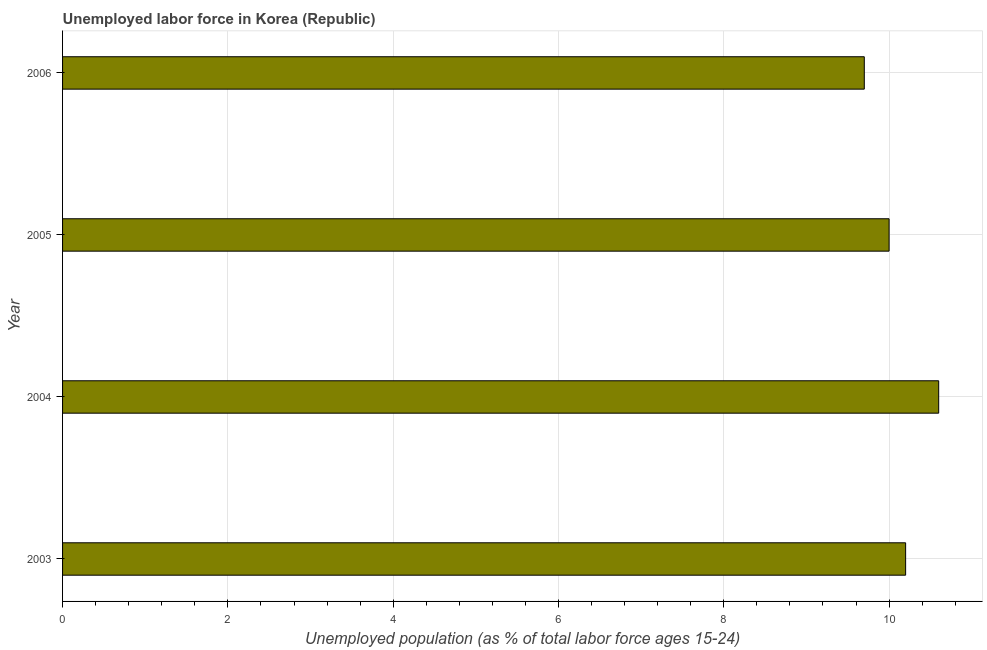Does the graph contain any zero values?
Offer a terse response. No. What is the title of the graph?
Provide a short and direct response. Unemployed labor force in Korea (Republic). What is the label or title of the X-axis?
Make the answer very short. Unemployed population (as % of total labor force ages 15-24). What is the label or title of the Y-axis?
Offer a terse response. Year. Across all years, what is the maximum total unemployed youth population?
Keep it short and to the point. 10.6. Across all years, what is the minimum total unemployed youth population?
Offer a terse response. 9.7. In which year was the total unemployed youth population maximum?
Give a very brief answer. 2004. In which year was the total unemployed youth population minimum?
Offer a terse response. 2006. What is the sum of the total unemployed youth population?
Give a very brief answer. 40.5. What is the average total unemployed youth population per year?
Give a very brief answer. 10.12. What is the median total unemployed youth population?
Your answer should be compact. 10.1. In how many years, is the total unemployed youth population greater than 7.6 %?
Your answer should be compact. 4. Do a majority of the years between 2006 and 2005 (inclusive) have total unemployed youth population greater than 3.2 %?
Your answer should be compact. No. What is the ratio of the total unemployed youth population in 2004 to that in 2006?
Provide a succinct answer. 1.09. Is the difference between the total unemployed youth population in 2003 and 2006 greater than the difference between any two years?
Your answer should be compact. No. Is the sum of the total unemployed youth population in 2005 and 2006 greater than the maximum total unemployed youth population across all years?
Offer a terse response. Yes. In how many years, is the total unemployed youth population greater than the average total unemployed youth population taken over all years?
Give a very brief answer. 2. How many bars are there?
Provide a succinct answer. 4. Are all the bars in the graph horizontal?
Make the answer very short. Yes. How many years are there in the graph?
Your answer should be compact. 4. What is the Unemployed population (as % of total labor force ages 15-24) of 2003?
Offer a terse response. 10.2. What is the Unemployed population (as % of total labor force ages 15-24) of 2004?
Give a very brief answer. 10.6. What is the Unemployed population (as % of total labor force ages 15-24) in 2006?
Offer a very short reply. 9.7. What is the difference between the Unemployed population (as % of total labor force ages 15-24) in 2003 and 2005?
Your answer should be compact. 0.2. What is the difference between the Unemployed population (as % of total labor force ages 15-24) in 2004 and 2005?
Keep it short and to the point. 0.6. What is the difference between the Unemployed population (as % of total labor force ages 15-24) in 2004 and 2006?
Give a very brief answer. 0.9. What is the difference between the Unemployed population (as % of total labor force ages 15-24) in 2005 and 2006?
Make the answer very short. 0.3. What is the ratio of the Unemployed population (as % of total labor force ages 15-24) in 2003 to that in 2004?
Keep it short and to the point. 0.96. What is the ratio of the Unemployed population (as % of total labor force ages 15-24) in 2003 to that in 2006?
Offer a terse response. 1.05. What is the ratio of the Unemployed population (as % of total labor force ages 15-24) in 2004 to that in 2005?
Ensure brevity in your answer.  1.06. What is the ratio of the Unemployed population (as % of total labor force ages 15-24) in 2004 to that in 2006?
Your answer should be compact. 1.09. What is the ratio of the Unemployed population (as % of total labor force ages 15-24) in 2005 to that in 2006?
Provide a succinct answer. 1.03. 